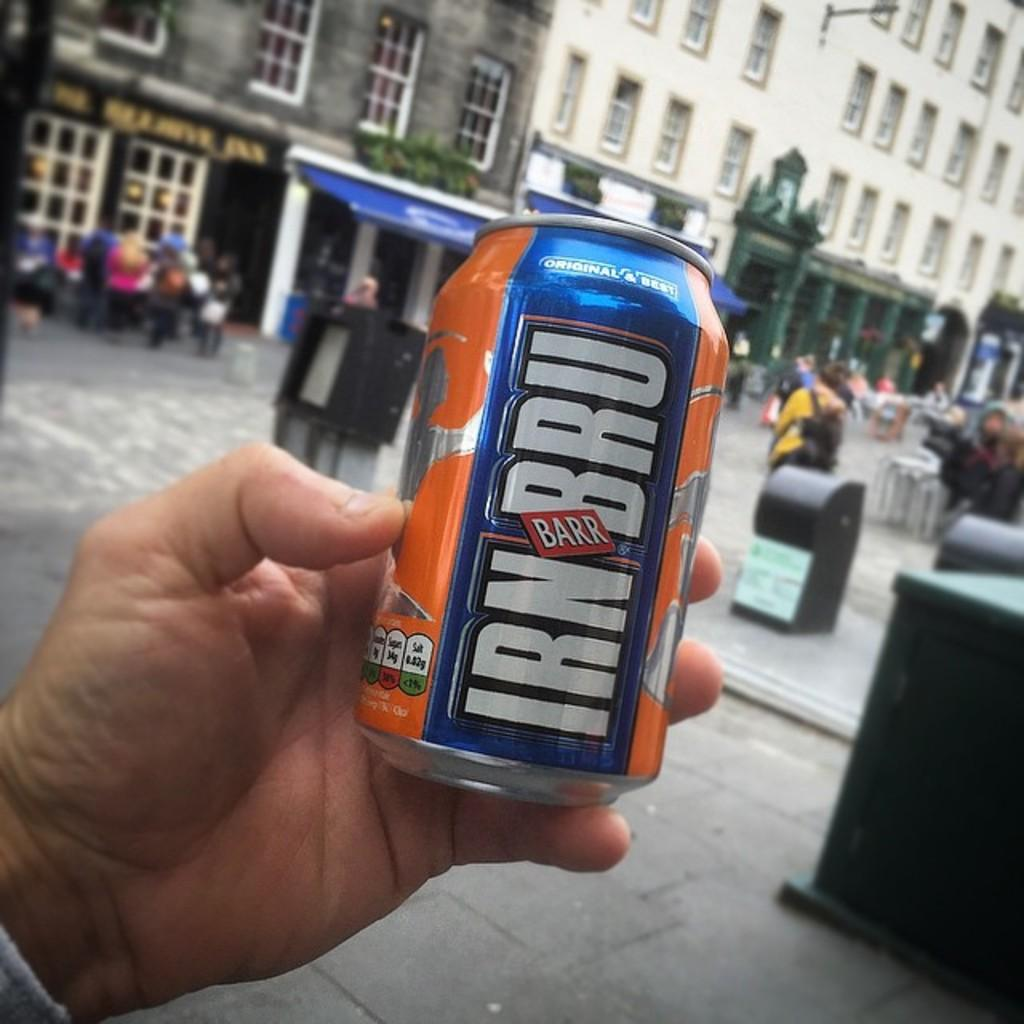<image>
Give a short and clear explanation of the subsequent image. Someone is holding a can of Irn Bru Barr beverage. 